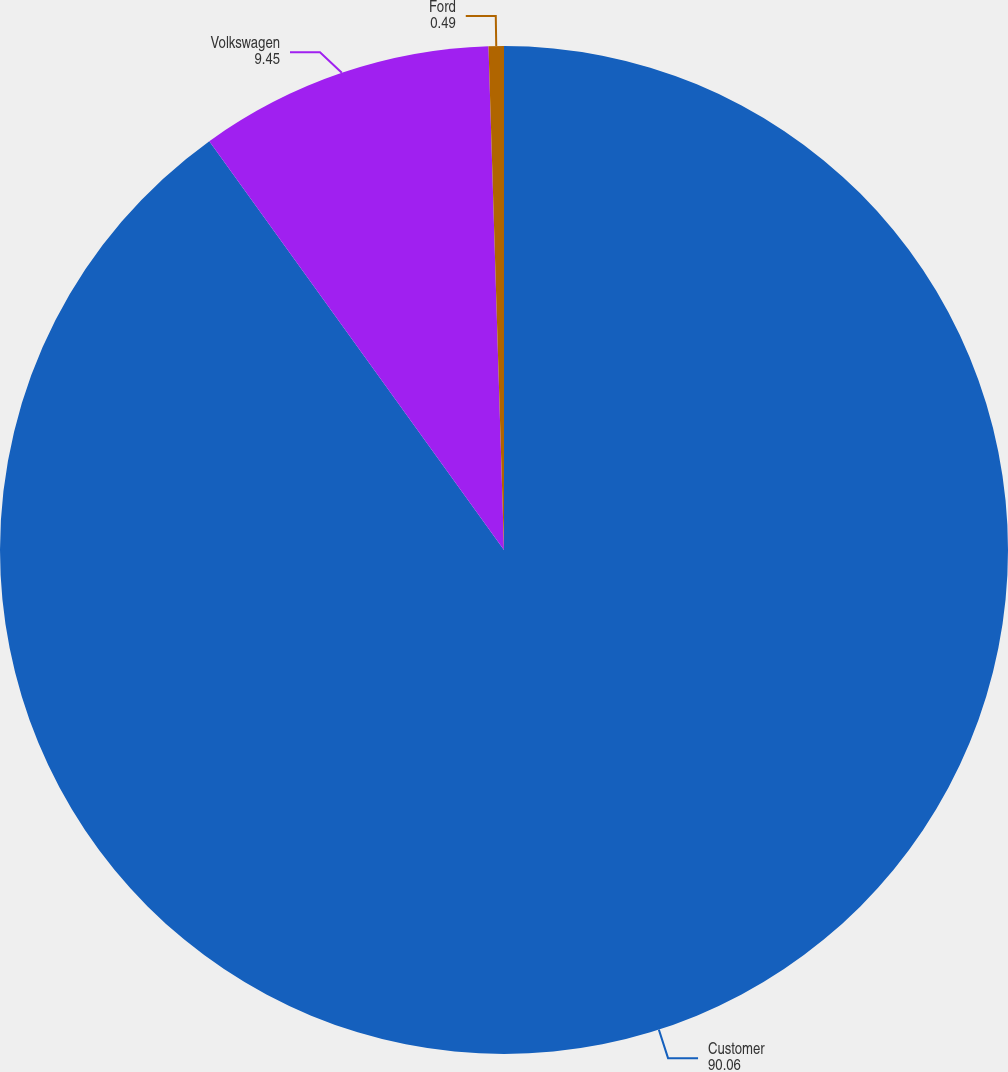<chart> <loc_0><loc_0><loc_500><loc_500><pie_chart><fcel>Customer<fcel>Volkswagen<fcel>Ford<nl><fcel>90.06%<fcel>9.45%<fcel>0.49%<nl></chart> 